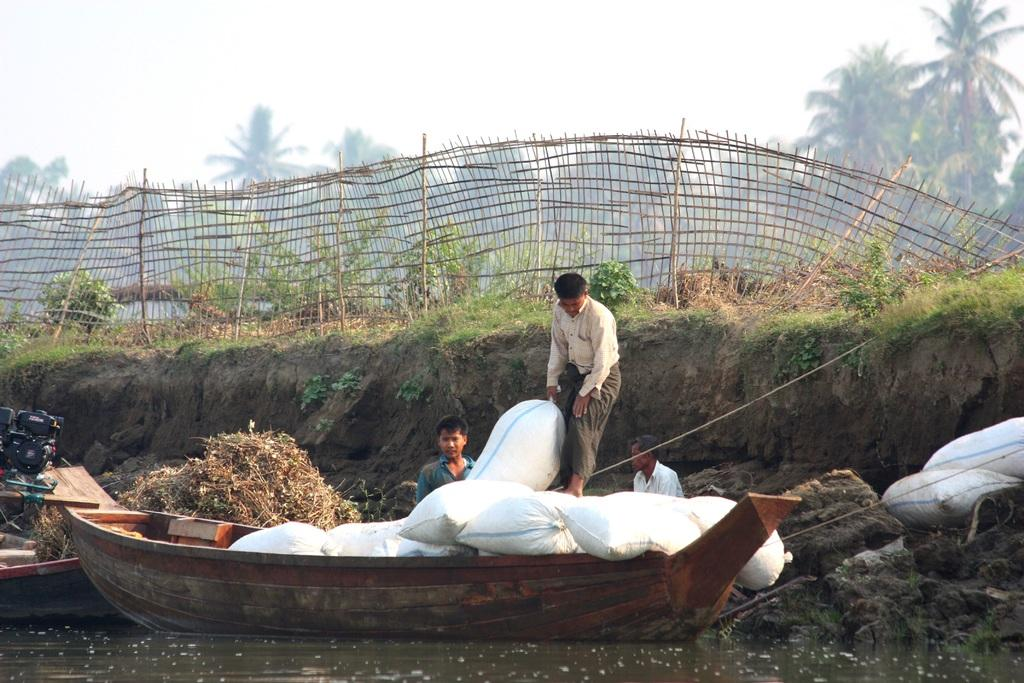What is in the water in the image? There are boats in the water in the image. What is on the boats? There are sacks on the boats. Can you identify any living beings in the image? Yes, there are people visible in the image. What type of natural environment is depicted in the image? The image features soil, trees, and water, suggesting a rural or agricultural setting. What is visible in the background of the image? The sky is visible in the background of the image. What type of berry is growing on the edge of the image? There is no berry present in the image, and the edge of the image is not a relevant concept in this context. 